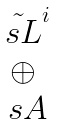<formula> <loc_0><loc_0><loc_500><loc_500>\begin{matrix} \tilde { \ s { L } } ^ { i } \\ \oplus \\ \ s { A } \end{matrix}</formula> 